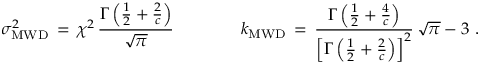<formula> <loc_0><loc_0><loc_500><loc_500>\sigma _ { M W D } ^ { 2 } \, = \, \chi ^ { 2 } \, \frac { \Gamma \left ( \frac { 1 } { 2 } + \frac { 2 } { c } \right ) } { \sqrt { \pi } } \quad k _ { M W D } \, = \, \frac { \Gamma \left ( \frac { 1 } { 2 } + \frac { 4 } { c } \right ) } { \left [ \Gamma \left ( \frac { 1 } { 2 } + \frac { 2 } { c } \right ) \right ] ^ { 2 } } \, \sqrt { \pi } - 3 \, .</formula> 